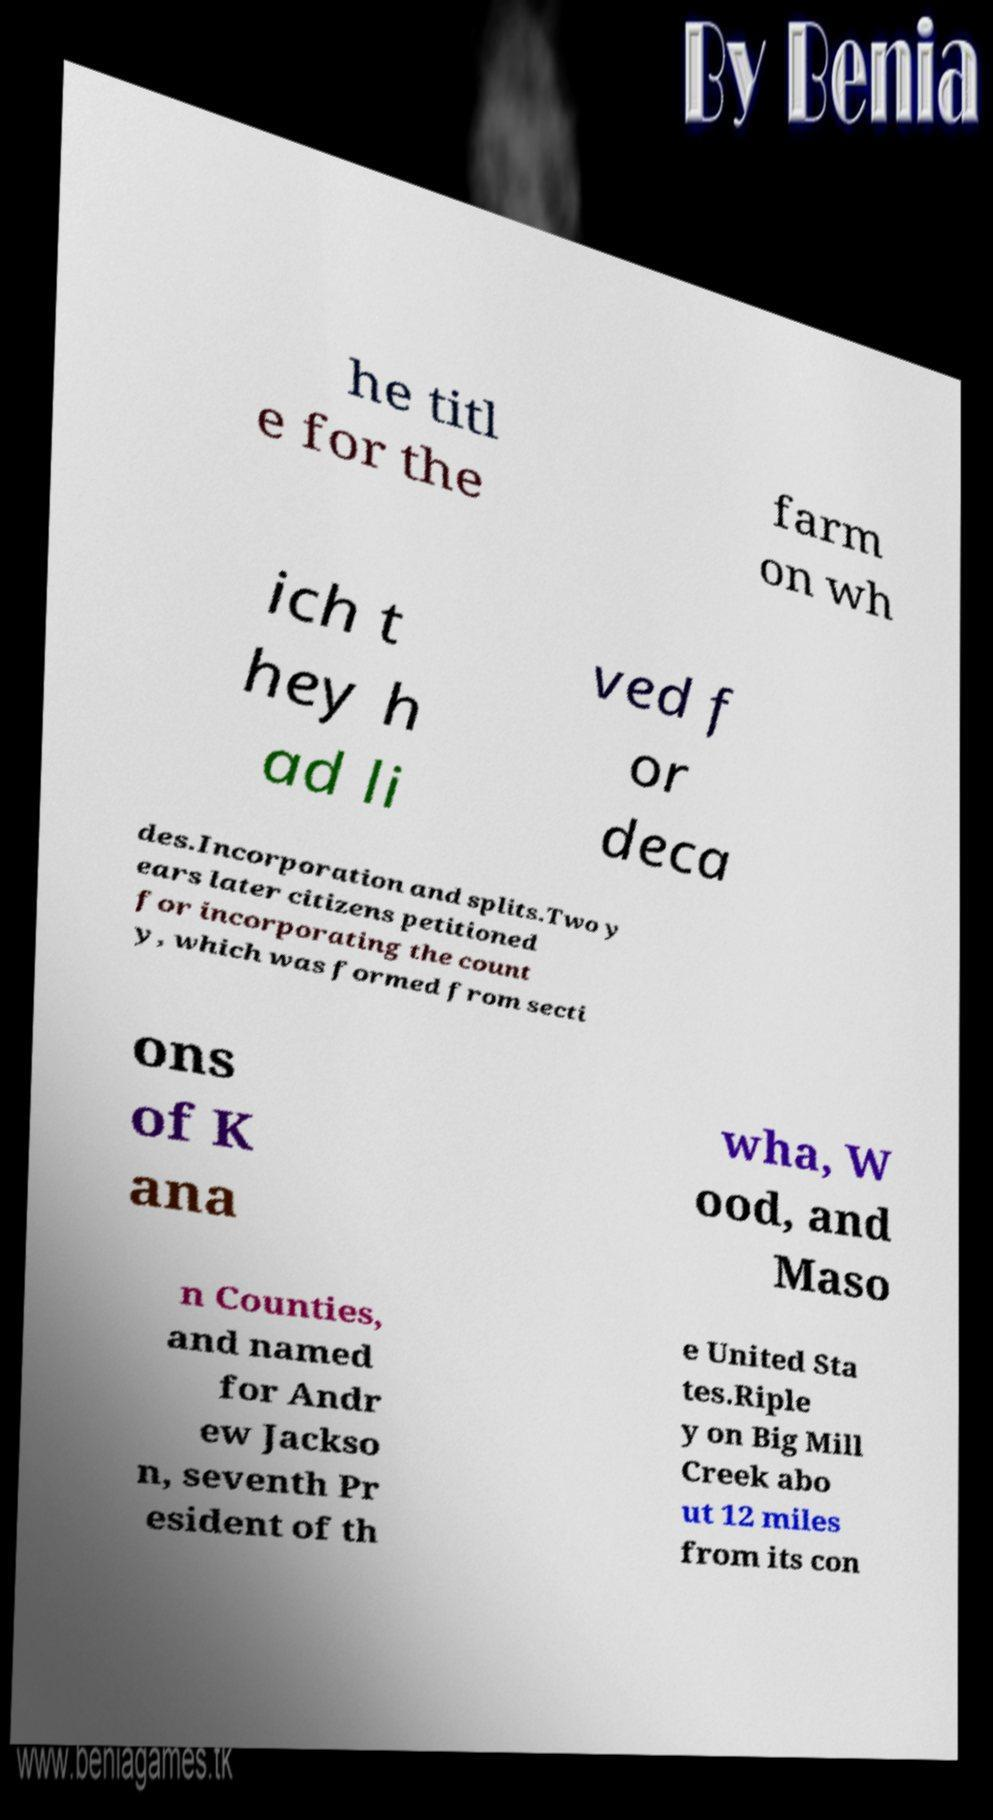I need the written content from this picture converted into text. Can you do that? he titl e for the farm on wh ich t hey h ad li ved f or deca des.Incorporation and splits.Two y ears later citizens petitioned for incorporating the count y, which was formed from secti ons of K ana wha, W ood, and Maso n Counties, and named for Andr ew Jackso n, seventh Pr esident of th e United Sta tes.Riple y on Big Mill Creek abo ut 12 miles from its con 